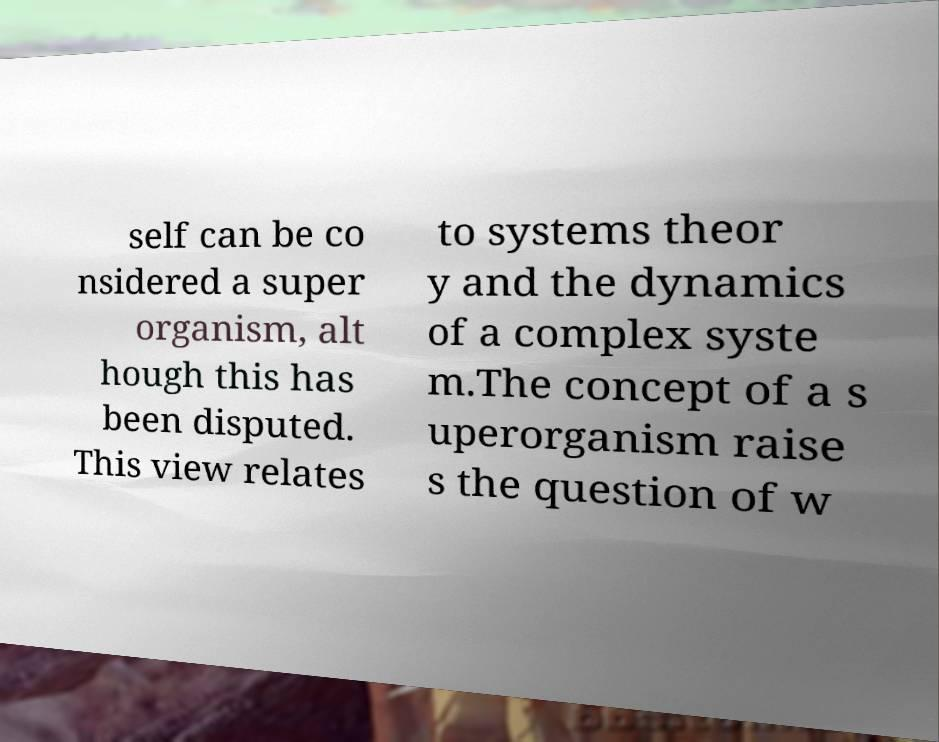For documentation purposes, I need the text within this image transcribed. Could you provide that? self can be co nsidered a super organism, alt hough this has been disputed. This view relates to systems theor y and the dynamics of a complex syste m.The concept of a s uperorganism raise s the question of w 